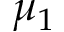<formula> <loc_0><loc_0><loc_500><loc_500>\mu _ { 1 }</formula> 